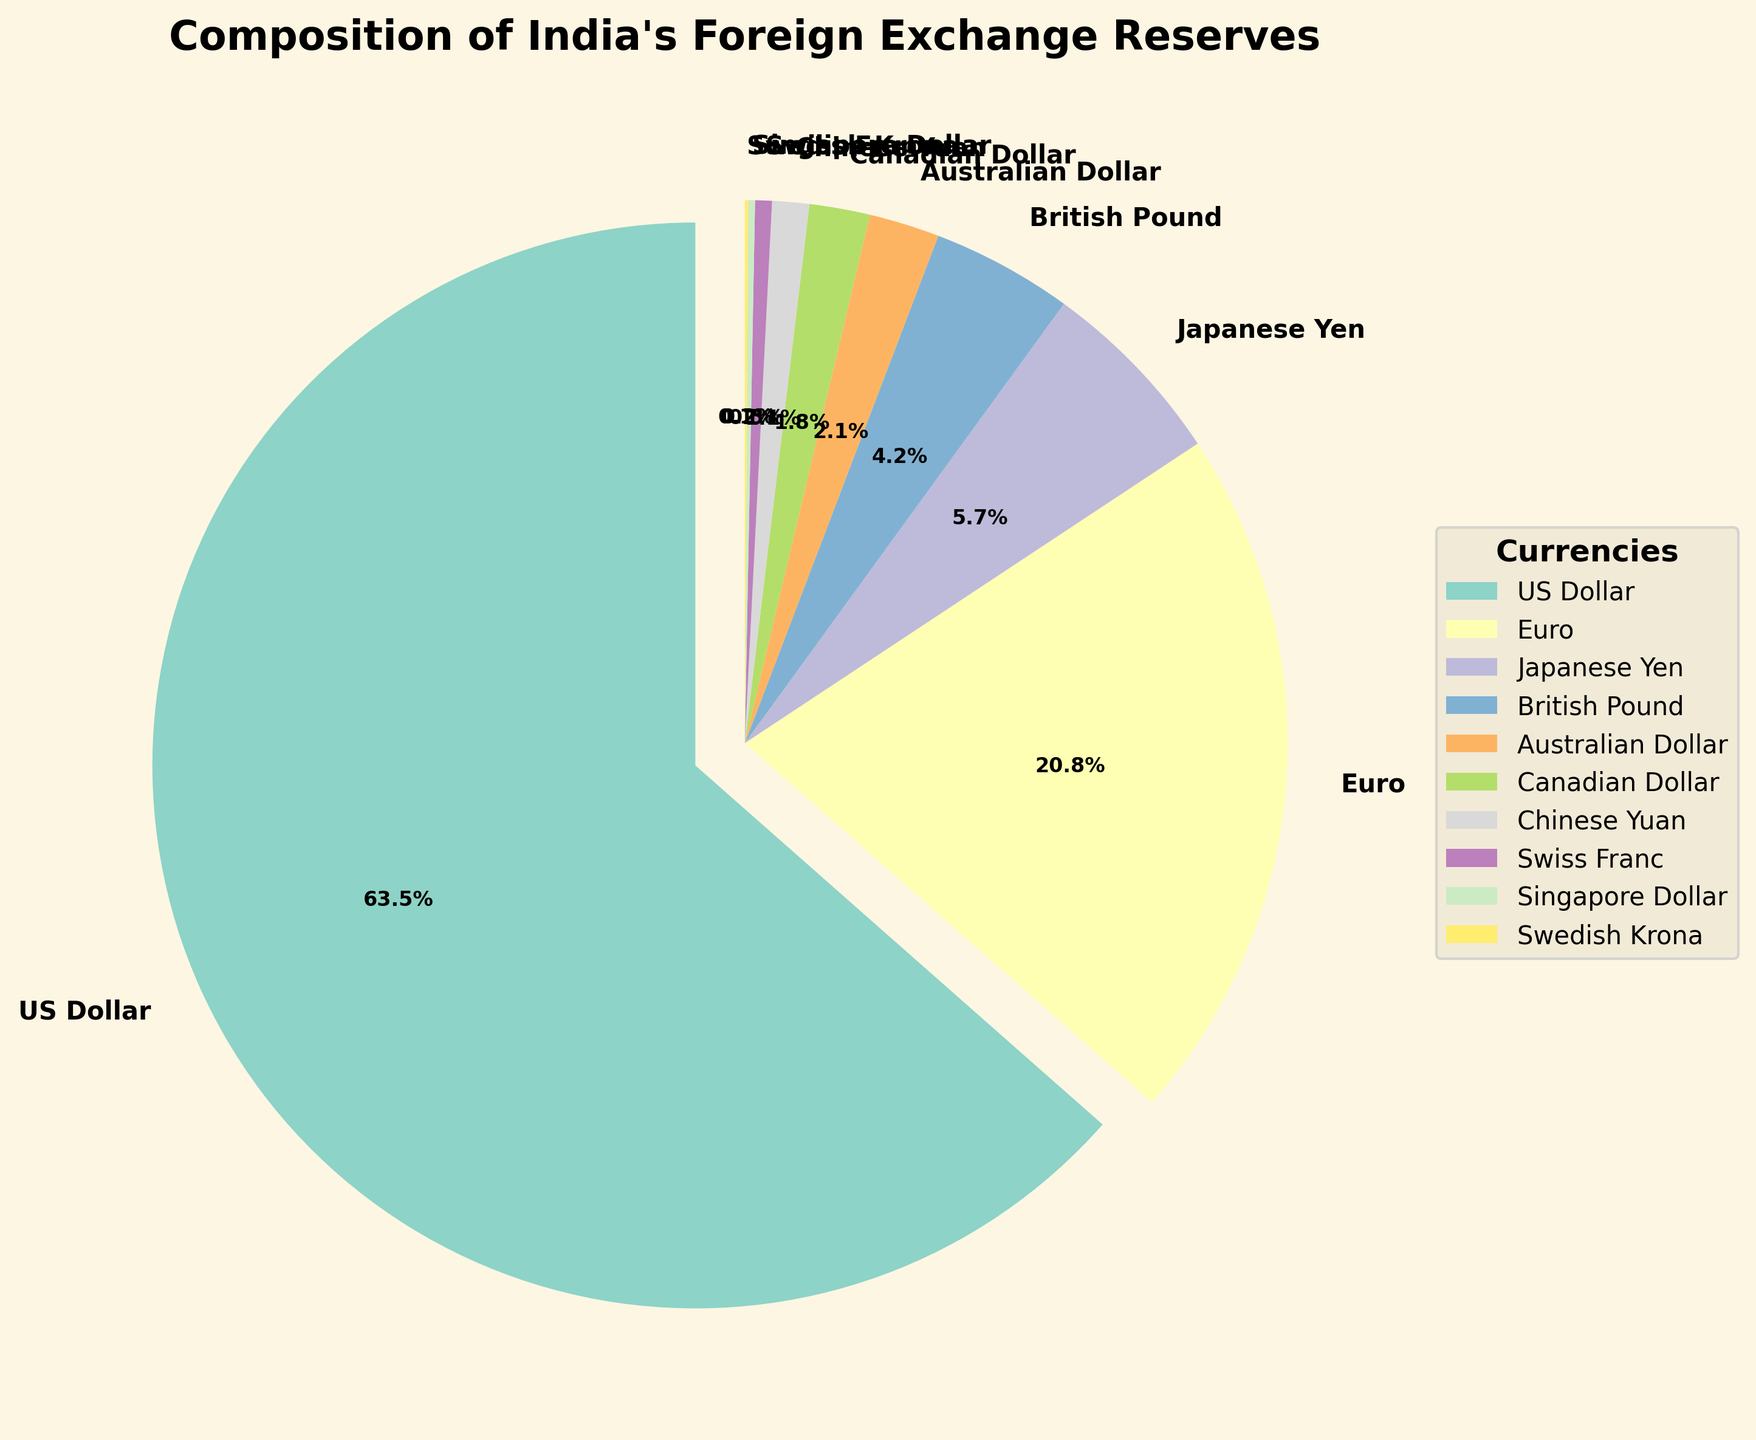What percentage of India's foreign exchange reserves is made up by currencies other than the US Dollar and Euro? Add the percentages of all the currencies except the US Dollar and Euro: 5.7 + 4.2 + 2.1 + 1.8 + 1.1 + 0.5 + 0.2 + 0.1 = 15.7%
Answer: 15.7% Which currency has the second largest share in India’s foreign exchange reserves? The second largest share is held by the currency with the second highest percentage, which is the Euro at 20.8%.
Answer: Euro By how much does the share of the US Dollar exceed the share of the Japanese Yen? Subtract the percentage of the Japanese Yen from the percentage of the US Dollar: 63.5 - 5.7 = 57.8%
Answer: 57.8% How much more significant is the US Dollar compared to all other Asian currencies combined (Japanese Yen and Chinese Yuan)? Add the percentages of the Japanese Yen and Chinese Yuan, then subtract from the US Dollar: (63.5 - (5.7 + 1.1)) = 63.5 - 6.8 = 56.7%
Answer: 56.7% Is the combined share of the British Pound and the Australian Dollar greater than the share of the Euro? Add the percentages of the British Pound and the Australian Dollar, then compare to the Euro: (4.2 + 2.1) = 6.3% < 20.8%
Answer: No Which currency takes up the smallest portion of India's foreign exchange reserves? The smallest portion is taken up by the currency with the lowest percentage, which is the Swedish Krona at 0.1%.
Answer: Swedish Krona What is the average share of the three smallest contributors (Canadian Dollar, Chinese Yuan, and Swedish Krona)? Add the percentages of these three currencies and divide by 3: (1.8 + 1.1 + 0.1) / 3 = 1.0%
Answer: 1.0% What is the total percentage of the top four contributing currencies in India’s foreign exchange reserves? Add the percentages of the top four currencies (US Dollar, Euro, Japanese Yen, and British Pound): (63.5 + 20.8 + 5.7 + 4.2) = 94.2%
Answer: 94.2% How many times bigger is the share of the US Dollar compared to the Swiss Franc? Divide the percentage of the US Dollar by the percentage of the Swiss Franc: 63.5 / 0.5 = 127
Answer: 127 times 